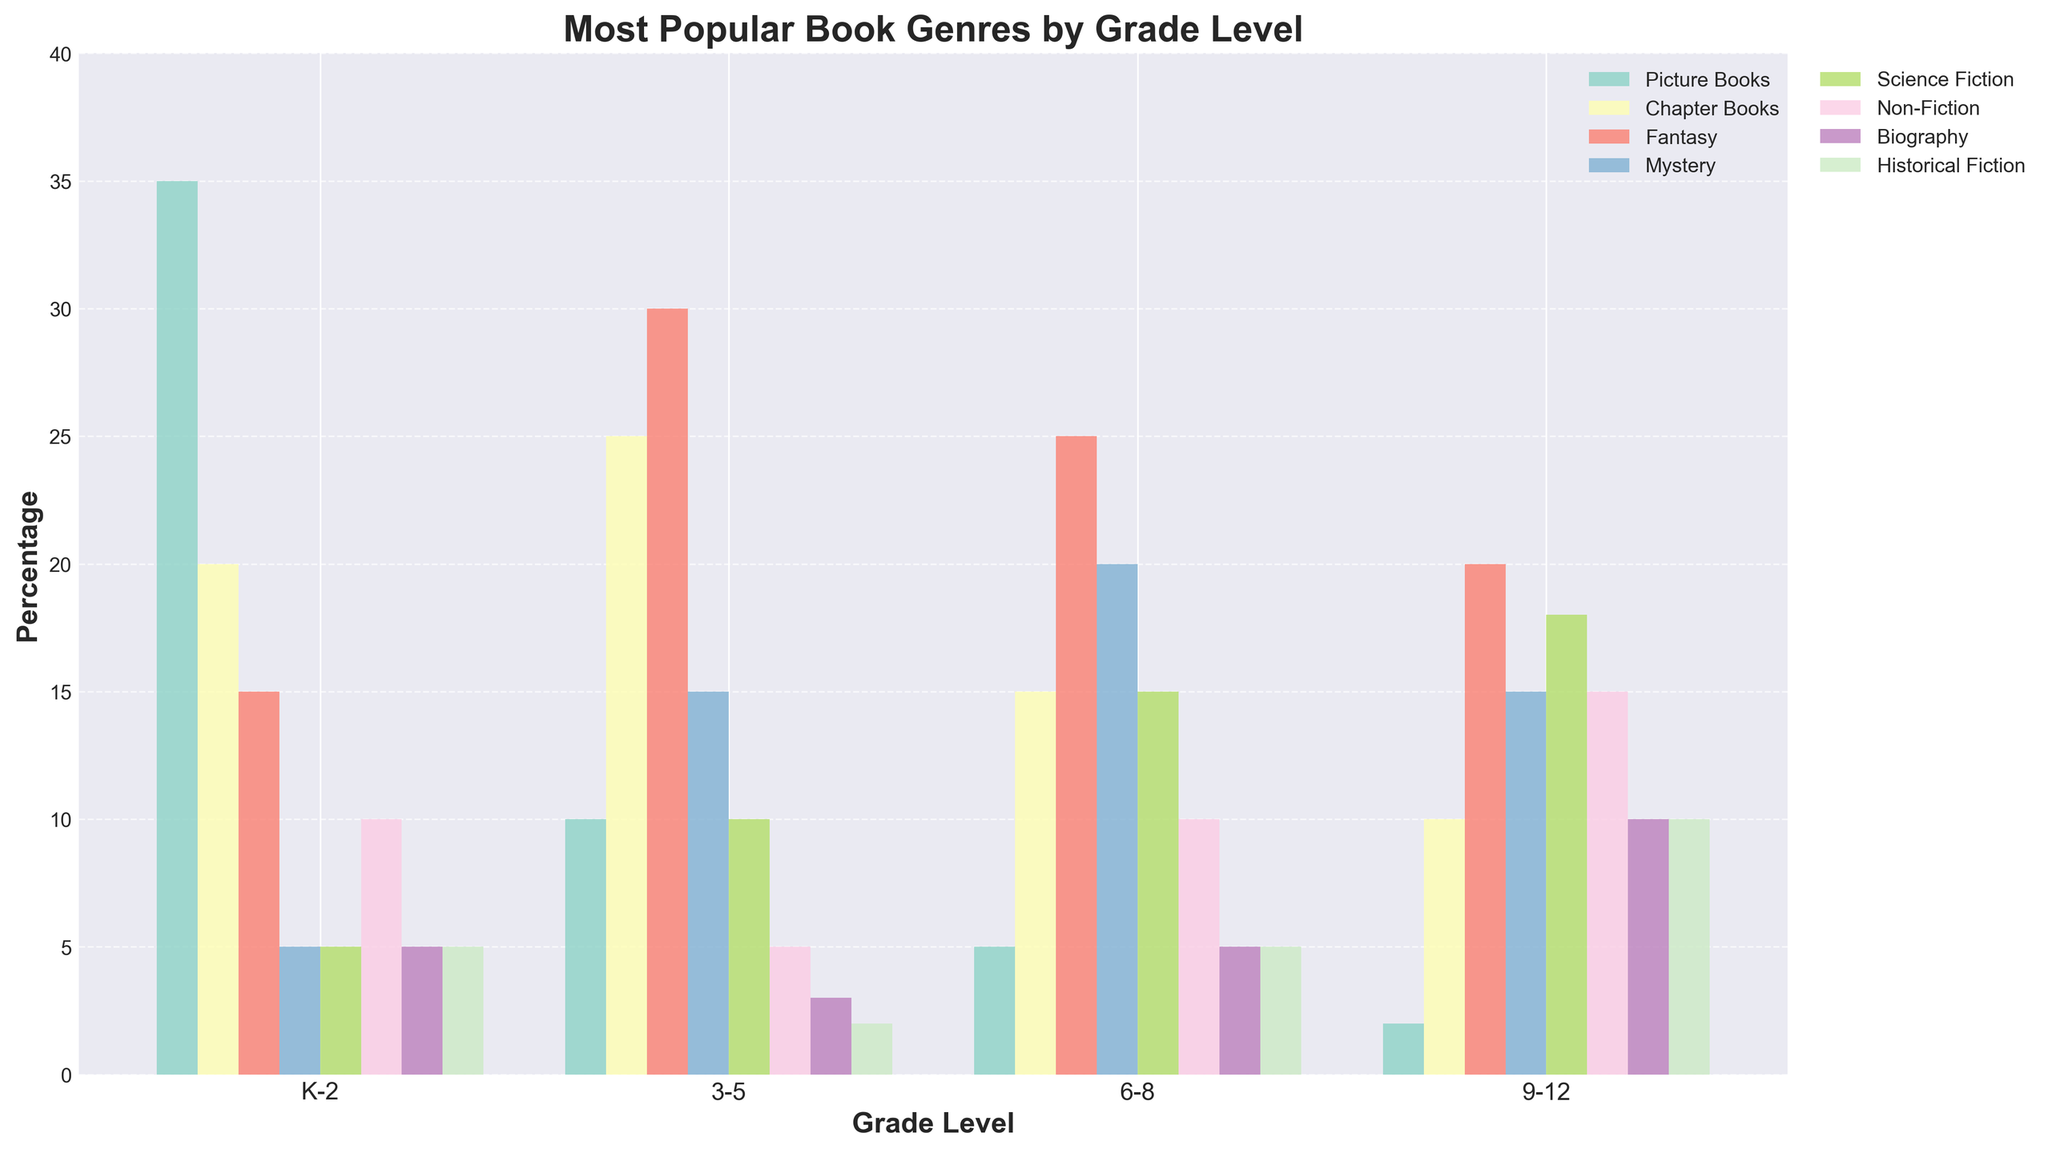Which genre is most popular among K-2 students? Look at the bar heights for each genre in the K-2 grade level and find the highest one.
Answer: Picture Books Which grade has the highest percentage of Chapter Books borrowed? Compare the length of the Chapter Books bars across all grade levels.
Answer: Grades 3-5 How does the popularity of Fantasy books change from K-2 to 9-12? Compare the heights of the bars representing Fantasy books for K-2 and 9-12. The bar height increases from 15 (K-2) to 20 (9-12).
Answer: Increases Which grade shows the most diversity in genre preferences? Look for the grade with the most evenly distributed bars across genres.
Answer: Grades 6-8 In which grade level is Non-Fiction borrowed the most? Find the tallest bar for Non-Fiction across all grade levels.
Answer: Grades 9-12 What is the difference in the percentage of Mystery books borrowed between grades 6-8 and 3-5? Subtract the height value of the Mystery bar in grades 3-5 from the one in grades 6-8: 20 - 15 = 5.
Answer: 5 Which two genres combined are the most popular among 9-12 students? Identify the two tallest bars in the 9-12 grade level and sum their percentages.
Answer: Science Fiction and Non-Fiction How does the popularity of Biography books compare between K-2 and 9-12? Compare the heights of the Biography bars for K-2 (5) and 9-12 (10).
Answer: 9-12 has more Among grades 3-5 students, what is the combined percentage of Picture Books and Science Fiction? Add the heights of the Picture Books and Science Fiction bars for 3-5 (10 + 10).
Answer: 20 